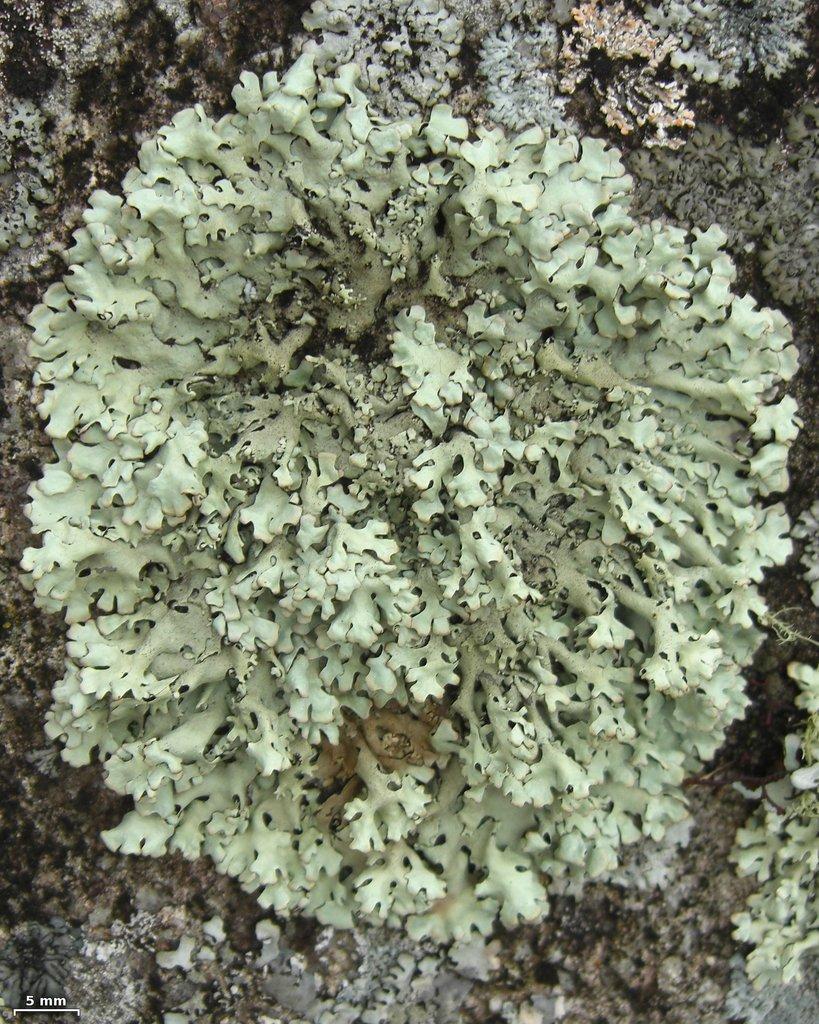In one or two sentences, can you explain what this image depicts? In this image we can see some fungus. 